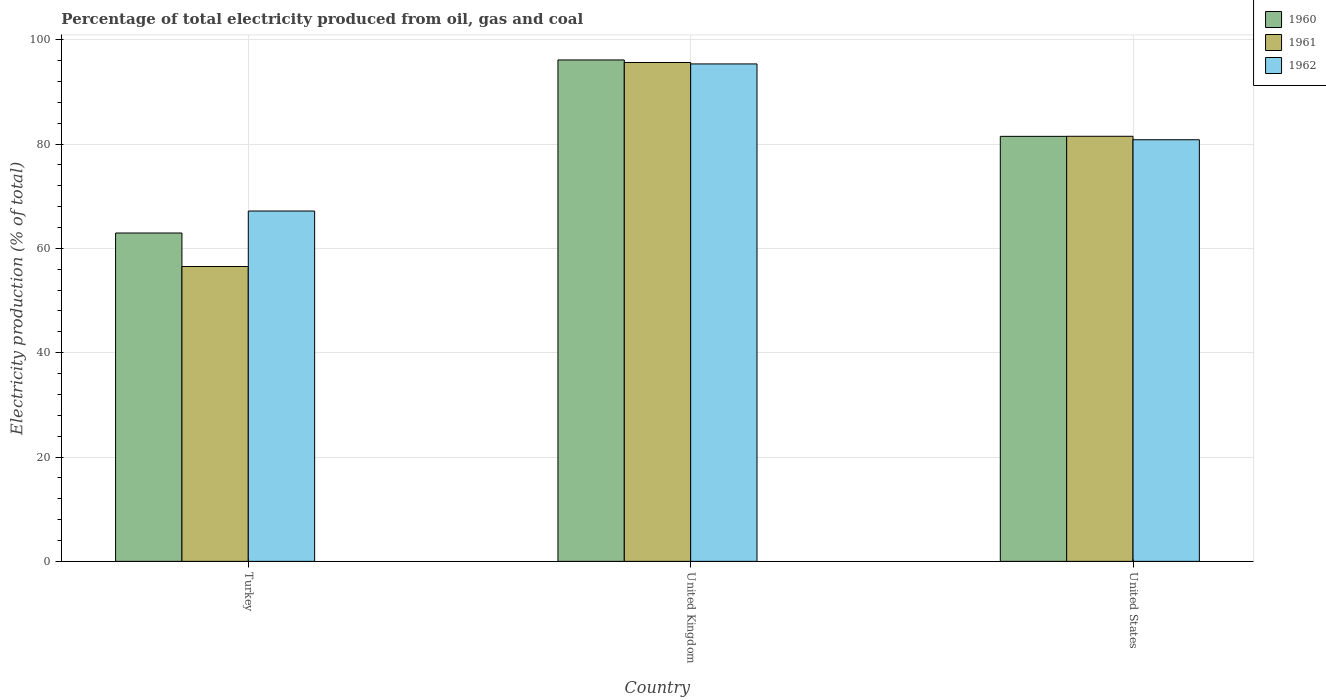How many different coloured bars are there?
Make the answer very short. 3. How many groups of bars are there?
Ensure brevity in your answer.  3. How many bars are there on the 3rd tick from the left?
Offer a very short reply. 3. How many bars are there on the 3rd tick from the right?
Give a very brief answer. 3. In how many cases, is the number of bars for a given country not equal to the number of legend labels?
Provide a short and direct response. 0. What is the electricity production in in 1960 in United Kingdom?
Your answer should be very brief. 96.12. Across all countries, what is the maximum electricity production in in 1960?
Your response must be concise. 96.12. Across all countries, what is the minimum electricity production in in 1961?
Keep it short and to the point. 56.53. In which country was the electricity production in in 1961 maximum?
Provide a short and direct response. United Kingdom. In which country was the electricity production in in 1962 minimum?
Ensure brevity in your answer.  Turkey. What is the total electricity production in in 1961 in the graph?
Provide a succinct answer. 233.65. What is the difference between the electricity production in in 1961 in Turkey and that in United Kingdom?
Keep it short and to the point. -39.11. What is the difference between the electricity production in in 1962 in United States and the electricity production in in 1961 in United Kingdom?
Your answer should be very brief. -14.81. What is the average electricity production in in 1962 per country?
Your answer should be very brief. 81.12. What is the difference between the electricity production in of/in 1960 and electricity production in of/in 1961 in Turkey?
Provide a short and direct response. 6.42. What is the ratio of the electricity production in in 1962 in United Kingdom to that in United States?
Ensure brevity in your answer.  1.18. Is the electricity production in in 1960 in Turkey less than that in United States?
Keep it short and to the point. Yes. Is the difference between the electricity production in in 1960 in Turkey and United Kingdom greater than the difference between the electricity production in in 1961 in Turkey and United Kingdom?
Make the answer very short. Yes. What is the difference between the highest and the second highest electricity production in in 1961?
Your response must be concise. -24.97. What is the difference between the highest and the lowest electricity production in in 1962?
Offer a very short reply. 28.2. In how many countries, is the electricity production in in 1961 greater than the average electricity production in in 1961 taken over all countries?
Give a very brief answer. 2. Is the sum of the electricity production in in 1962 in Turkey and United States greater than the maximum electricity production in in 1960 across all countries?
Provide a succinct answer. Yes. What does the 2nd bar from the right in United States represents?
Provide a succinct answer. 1961. Is it the case that in every country, the sum of the electricity production in in 1962 and electricity production in in 1960 is greater than the electricity production in in 1961?
Provide a short and direct response. Yes. How many bars are there?
Your answer should be compact. 9. How many countries are there in the graph?
Ensure brevity in your answer.  3. Are the values on the major ticks of Y-axis written in scientific E-notation?
Make the answer very short. No. Does the graph contain any zero values?
Your answer should be very brief. No. Where does the legend appear in the graph?
Your response must be concise. Top right. How are the legend labels stacked?
Your response must be concise. Vertical. What is the title of the graph?
Provide a succinct answer. Percentage of total electricity produced from oil, gas and coal. What is the label or title of the Y-axis?
Provide a succinct answer. Electricity production (% of total). What is the Electricity production (% of total) of 1960 in Turkey?
Your response must be concise. 62.95. What is the Electricity production (% of total) of 1961 in Turkey?
Your response must be concise. 56.53. What is the Electricity production (% of total) of 1962 in Turkey?
Your answer should be very brief. 67.16. What is the Electricity production (% of total) of 1960 in United Kingdom?
Offer a terse response. 96.12. What is the Electricity production (% of total) in 1961 in United Kingdom?
Offer a terse response. 95.64. What is the Electricity production (% of total) in 1962 in United Kingdom?
Provide a short and direct response. 95.36. What is the Electricity production (% of total) of 1960 in United States?
Offer a very short reply. 81.48. What is the Electricity production (% of total) in 1961 in United States?
Make the answer very short. 81.49. What is the Electricity production (% of total) in 1962 in United States?
Provide a succinct answer. 80.83. Across all countries, what is the maximum Electricity production (% of total) in 1960?
Your answer should be compact. 96.12. Across all countries, what is the maximum Electricity production (% of total) in 1961?
Offer a very short reply. 95.64. Across all countries, what is the maximum Electricity production (% of total) of 1962?
Give a very brief answer. 95.36. Across all countries, what is the minimum Electricity production (% of total) of 1960?
Your answer should be compact. 62.95. Across all countries, what is the minimum Electricity production (% of total) of 1961?
Keep it short and to the point. 56.53. Across all countries, what is the minimum Electricity production (% of total) in 1962?
Your answer should be compact. 67.16. What is the total Electricity production (% of total) of 1960 in the graph?
Your answer should be compact. 240.55. What is the total Electricity production (% of total) in 1961 in the graph?
Ensure brevity in your answer.  233.65. What is the total Electricity production (% of total) of 1962 in the graph?
Provide a succinct answer. 243.35. What is the difference between the Electricity production (% of total) of 1960 in Turkey and that in United Kingdom?
Provide a short and direct response. -33.18. What is the difference between the Electricity production (% of total) of 1961 in Turkey and that in United Kingdom?
Provide a short and direct response. -39.11. What is the difference between the Electricity production (% of total) of 1962 in Turkey and that in United Kingdom?
Offer a terse response. -28.2. What is the difference between the Electricity production (% of total) in 1960 in Turkey and that in United States?
Your answer should be very brief. -18.53. What is the difference between the Electricity production (% of total) in 1961 in Turkey and that in United States?
Your response must be concise. -24.97. What is the difference between the Electricity production (% of total) in 1962 in Turkey and that in United States?
Give a very brief answer. -13.66. What is the difference between the Electricity production (% of total) in 1960 in United Kingdom and that in United States?
Ensure brevity in your answer.  14.65. What is the difference between the Electricity production (% of total) of 1961 in United Kingdom and that in United States?
Provide a succinct answer. 14.14. What is the difference between the Electricity production (% of total) in 1962 in United Kingdom and that in United States?
Your answer should be compact. 14.53. What is the difference between the Electricity production (% of total) in 1960 in Turkey and the Electricity production (% of total) in 1961 in United Kingdom?
Give a very brief answer. -32.69. What is the difference between the Electricity production (% of total) of 1960 in Turkey and the Electricity production (% of total) of 1962 in United Kingdom?
Give a very brief answer. -32.41. What is the difference between the Electricity production (% of total) in 1961 in Turkey and the Electricity production (% of total) in 1962 in United Kingdom?
Your response must be concise. -38.83. What is the difference between the Electricity production (% of total) of 1960 in Turkey and the Electricity production (% of total) of 1961 in United States?
Offer a terse response. -18.54. What is the difference between the Electricity production (% of total) of 1960 in Turkey and the Electricity production (% of total) of 1962 in United States?
Provide a short and direct response. -17.88. What is the difference between the Electricity production (% of total) of 1961 in Turkey and the Electricity production (% of total) of 1962 in United States?
Your answer should be very brief. -24.3. What is the difference between the Electricity production (% of total) in 1960 in United Kingdom and the Electricity production (% of total) in 1961 in United States?
Keep it short and to the point. 14.63. What is the difference between the Electricity production (% of total) in 1960 in United Kingdom and the Electricity production (% of total) in 1962 in United States?
Keep it short and to the point. 15.3. What is the difference between the Electricity production (% of total) in 1961 in United Kingdom and the Electricity production (% of total) in 1962 in United States?
Your answer should be compact. 14.81. What is the average Electricity production (% of total) in 1960 per country?
Your answer should be very brief. 80.18. What is the average Electricity production (% of total) of 1961 per country?
Your answer should be compact. 77.88. What is the average Electricity production (% of total) of 1962 per country?
Keep it short and to the point. 81.12. What is the difference between the Electricity production (% of total) of 1960 and Electricity production (% of total) of 1961 in Turkey?
Offer a terse response. 6.42. What is the difference between the Electricity production (% of total) of 1960 and Electricity production (% of total) of 1962 in Turkey?
Make the answer very short. -4.21. What is the difference between the Electricity production (% of total) of 1961 and Electricity production (% of total) of 1962 in Turkey?
Your answer should be compact. -10.64. What is the difference between the Electricity production (% of total) of 1960 and Electricity production (% of total) of 1961 in United Kingdom?
Make the answer very short. 0.49. What is the difference between the Electricity production (% of total) in 1960 and Electricity production (% of total) in 1962 in United Kingdom?
Offer a very short reply. 0.76. What is the difference between the Electricity production (% of total) of 1961 and Electricity production (% of total) of 1962 in United Kingdom?
Keep it short and to the point. 0.28. What is the difference between the Electricity production (% of total) in 1960 and Electricity production (% of total) in 1961 in United States?
Make the answer very short. -0.02. What is the difference between the Electricity production (% of total) in 1960 and Electricity production (% of total) in 1962 in United States?
Provide a succinct answer. 0.65. What is the difference between the Electricity production (% of total) of 1961 and Electricity production (% of total) of 1962 in United States?
Keep it short and to the point. 0.66. What is the ratio of the Electricity production (% of total) in 1960 in Turkey to that in United Kingdom?
Offer a terse response. 0.65. What is the ratio of the Electricity production (% of total) of 1961 in Turkey to that in United Kingdom?
Give a very brief answer. 0.59. What is the ratio of the Electricity production (% of total) in 1962 in Turkey to that in United Kingdom?
Ensure brevity in your answer.  0.7. What is the ratio of the Electricity production (% of total) of 1960 in Turkey to that in United States?
Make the answer very short. 0.77. What is the ratio of the Electricity production (% of total) of 1961 in Turkey to that in United States?
Make the answer very short. 0.69. What is the ratio of the Electricity production (% of total) in 1962 in Turkey to that in United States?
Ensure brevity in your answer.  0.83. What is the ratio of the Electricity production (% of total) in 1960 in United Kingdom to that in United States?
Make the answer very short. 1.18. What is the ratio of the Electricity production (% of total) in 1961 in United Kingdom to that in United States?
Keep it short and to the point. 1.17. What is the ratio of the Electricity production (% of total) of 1962 in United Kingdom to that in United States?
Offer a terse response. 1.18. What is the difference between the highest and the second highest Electricity production (% of total) of 1960?
Offer a terse response. 14.65. What is the difference between the highest and the second highest Electricity production (% of total) of 1961?
Your response must be concise. 14.14. What is the difference between the highest and the second highest Electricity production (% of total) in 1962?
Make the answer very short. 14.53. What is the difference between the highest and the lowest Electricity production (% of total) of 1960?
Offer a very short reply. 33.18. What is the difference between the highest and the lowest Electricity production (% of total) in 1961?
Your answer should be compact. 39.11. What is the difference between the highest and the lowest Electricity production (% of total) of 1962?
Your answer should be compact. 28.2. 